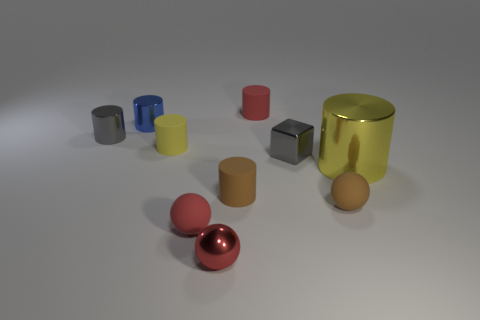What number of metal cylinders have the same color as the big object?
Keep it short and to the point. 0. There is a red metal thing that is the same size as the brown sphere; what shape is it?
Give a very brief answer. Sphere. Are there any large gray rubber objects that have the same shape as the small red metallic thing?
Give a very brief answer. No. How many other large yellow things are made of the same material as the large yellow object?
Make the answer very short. 0. Are the tiny ball on the right side of the small red metal thing and the blue object made of the same material?
Make the answer very short. No. Are there more big objects that are left of the large metallic object than small rubber objects right of the tiny red metallic ball?
Your answer should be very brief. No. There is a gray object that is the same size as the gray cube; what is it made of?
Keep it short and to the point. Metal. There is a small gray metal thing that is left of the small cube; is it the same shape as the small gray thing that is right of the metallic ball?
Make the answer very short. No. What number of other things are there of the same color as the block?
Make the answer very short. 1. Is the material of the small cylinder that is in front of the large yellow object the same as the thing that is behind the tiny blue cylinder?
Your response must be concise. Yes. 